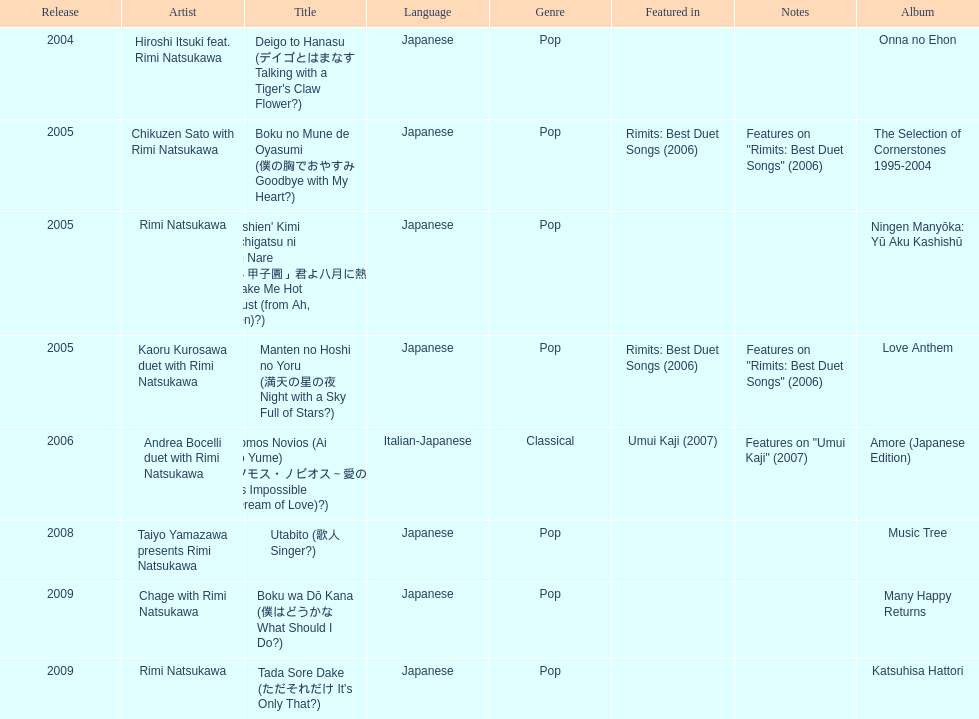What year was the first title released? 2004. 